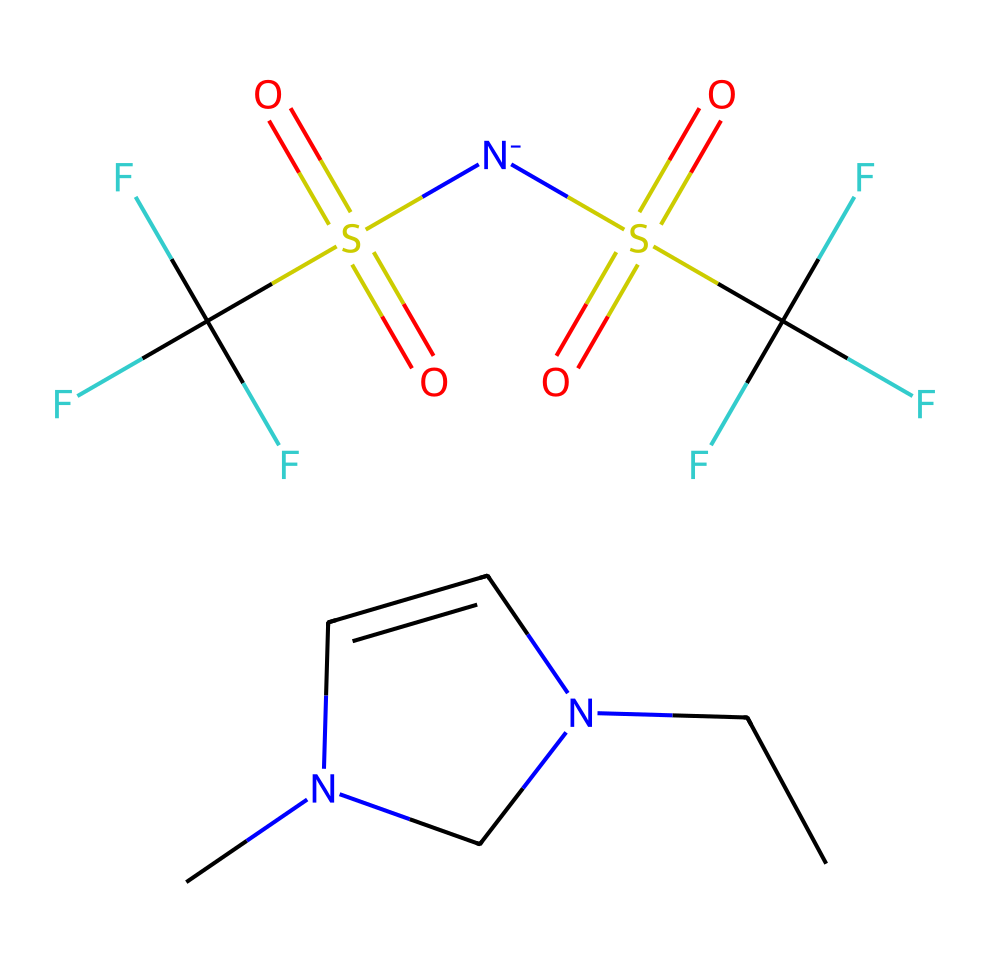What is the total number of carbon atoms in this ionic liquid? By examining the provided SMILES representation, we can count the carbon atoms (C). The notation "CCN1C=CN(C)C1" indicates there are four carbon atoms in the first part and two carbon atoms in the second part represented by "C(F)(F)F." In total, there are six carbon atoms.
Answer: six How many nitrogen atoms are present? In the SMILES, the nitrogen atoms (N) appear within the structure. The first part has one nitrogen and the second part has one nitrogen. Therefore, the total number of nitrogen atoms in the representation is two.
Answer: two What can be inferred about the solubility of this ionic liquid? Ionic liquids are generally soluble in both polar and non-polar solvents due to their ionic nature. The presence of a long hydrophobic fluorinated chain (represented by "C(F)(F)F") suggests they can dissolve in nonpolar environments but still maintain some degree of polarity, affecting solubility.
Answer: polar and non-polar What functional groups are present in the molecule? In the SMILES, the groups that can be identified include sulfonyl (S(=O)(=O)) and the amidine group (C=CN). The presence of these functional groups indicates characteristics like high polarity and potential for interaction with various surfaces, which enhances their cleaning ability.
Answer: sulfonyl, amidine Is this ionic liquid believed to be hazardous? According to the component "C(F)(F)F," which represents a fluorinated compound, many fluorinated chemicals exhibit toxicity and environmental concerns. Thus, this particular ionic liquid may involve hazardous properties.
Answer: yes What functional role do the sulfonate groups play? The sulfonate groups (S(=O)(=O)) within the ionic liquid enhance its interaction with dirt and contaminants on surfaces. This interaction is crucial for cleaning activities, making the sulfonate groups important for its effectiveness as a cleaner.
Answer: increase cleaning effectiveness Which type of chemical bond is prevalent in this structure? The prominent types of bonds within the structure include ionic bonds (between the cation and anion components) and covalent bonds (in the carbon and nitrogen moieties). This combination is what characterizes ionic liquids distinctly.
Answer: ionic and covalent 